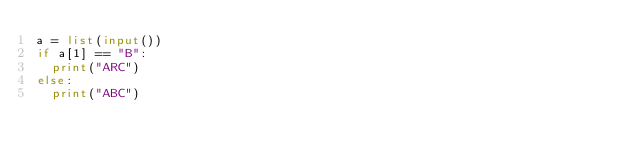Convert code to text. <code><loc_0><loc_0><loc_500><loc_500><_Python_>a = list(input())
if a[1] == "B":
  print("ARC")
else:
  print("ABC")</code> 